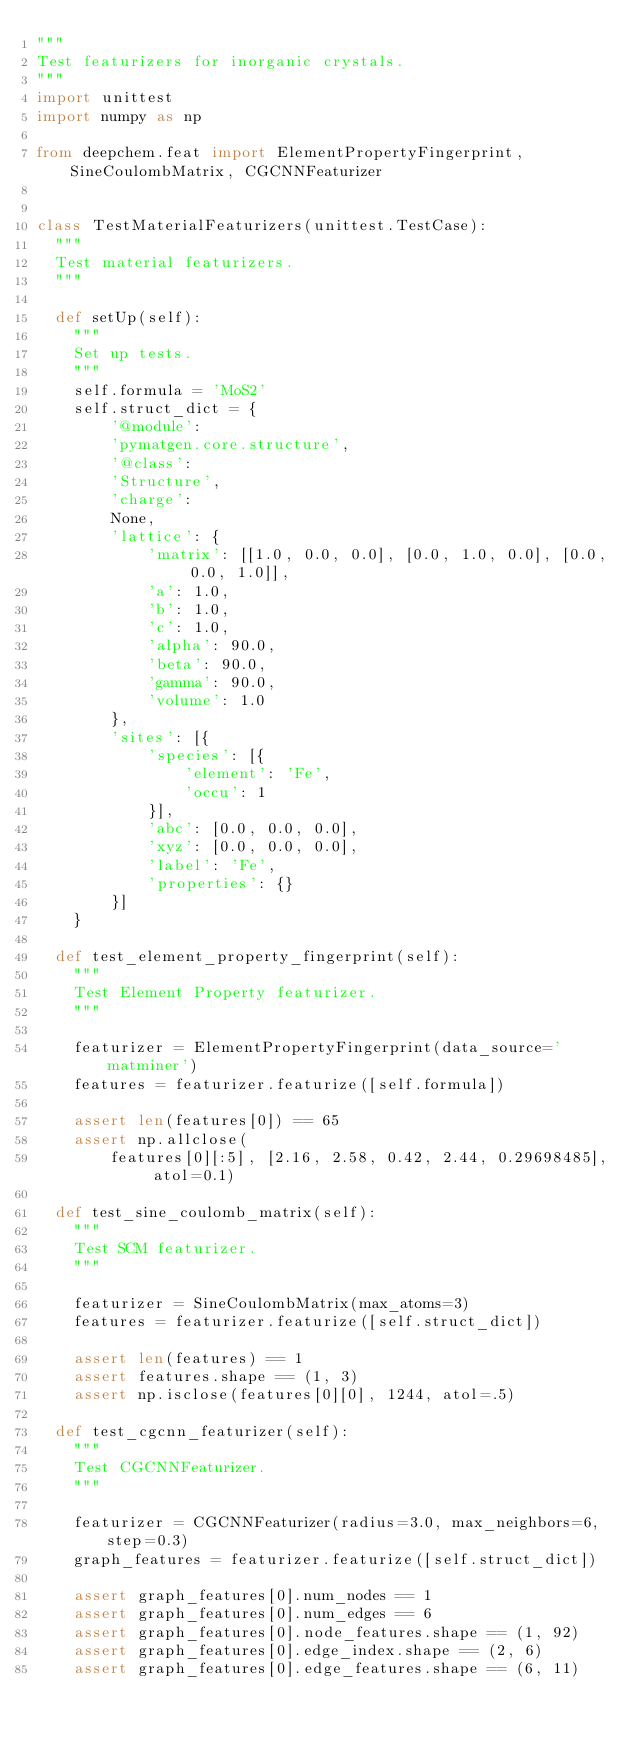<code> <loc_0><loc_0><loc_500><loc_500><_Python_>"""
Test featurizers for inorganic crystals.
"""
import unittest
import numpy as np

from deepchem.feat import ElementPropertyFingerprint, SineCoulombMatrix, CGCNNFeaturizer


class TestMaterialFeaturizers(unittest.TestCase):
  """
  Test material featurizers.
  """

  def setUp(self):
    """
    Set up tests.
    """
    self.formula = 'MoS2'
    self.struct_dict = {
        '@module':
        'pymatgen.core.structure',
        '@class':
        'Structure',
        'charge':
        None,
        'lattice': {
            'matrix': [[1.0, 0.0, 0.0], [0.0, 1.0, 0.0], [0.0, 0.0, 1.0]],
            'a': 1.0,
            'b': 1.0,
            'c': 1.0,
            'alpha': 90.0,
            'beta': 90.0,
            'gamma': 90.0,
            'volume': 1.0
        },
        'sites': [{
            'species': [{
                'element': 'Fe',
                'occu': 1
            }],
            'abc': [0.0, 0.0, 0.0],
            'xyz': [0.0, 0.0, 0.0],
            'label': 'Fe',
            'properties': {}
        }]
    }

  def test_element_property_fingerprint(self):
    """
    Test Element Property featurizer.
    """

    featurizer = ElementPropertyFingerprint(data_source='matminer')
    features = featurizer.featurize([self.formula])

    assert len(features[0]) == 65
    assert np.allclose(
        features[0][:5], [2.16, 2.58, 0.42, 2.44, 0.29698485], atol=0.1)

  def test_sine_coulomb_matrix(self):
    """
    Test SCM featurizer.
    """

    featurizer = SineCoulombMatrix(max_atoms=3)
    features = featurizer.featurize([self.struct_dict])

    assert len(features) == 1
    assert features.shape == (1, 3)
    assert np.isclose(features[0][0], 1244, atol=.5)

  def test_cgcnn_featurizer(self):
    """
    Test CGCNNFeaturizer.
    """

    featurizer = CGCNNFeaturizer(radius=3.0, max_neighbors=6, step=0.3)
    graph_features = featurizer.featurize([self.struct_dict])

    assert graph_features[0].num_nodes == 1
    assert graph_features[0].num_edges == 6
    assert graph_features[0].node_features.shape == (1, 92)
    assert graph_features[0].edge_index.shape == (2, 6)
    assert graph_features[0].edge_features.shape == (6, 11)
</code> 